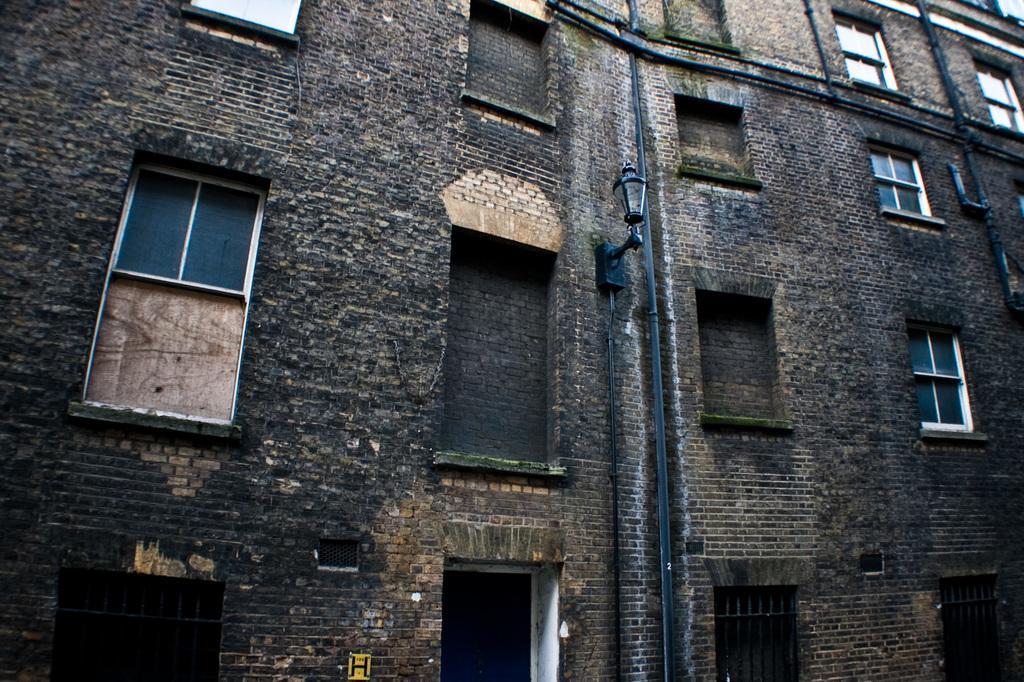In one or two sentences, can you explain what this image depicts? In this image I can see a building. On the building wall I can see windows, light and other objects. 